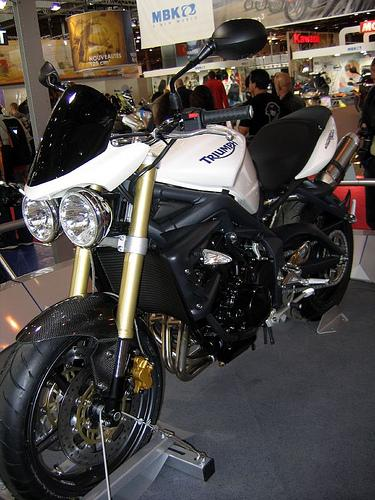What kind of bike is this? motorcycle 